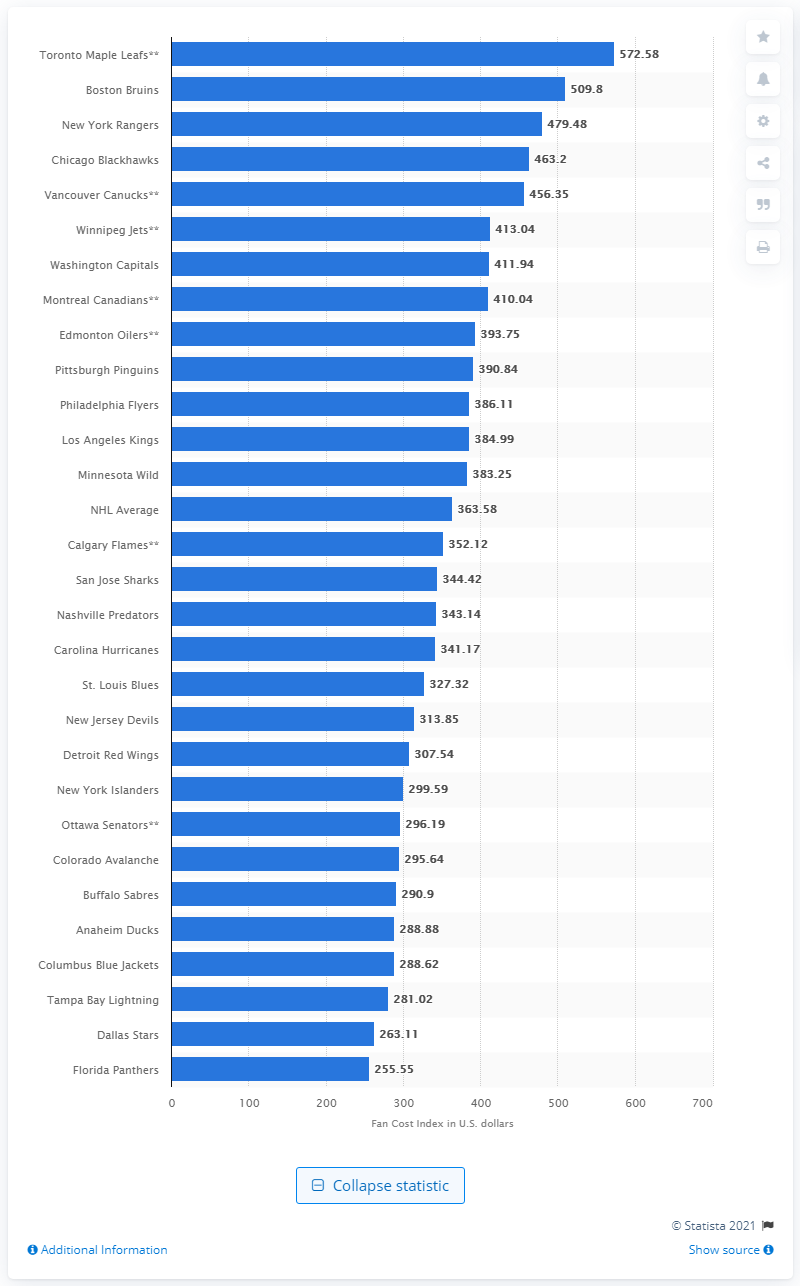Outline some significant characteristics in this image. The average cost of attending a National Hockey League (NHL) game is approximately $363.58. According to the Fan Cost Index, the New York Rangers are ranked as the team with the highest cost for fans to attend a game. In the 2014/15 season, the Fan Cost Index for the New York Rangers was 479.48. 